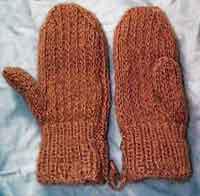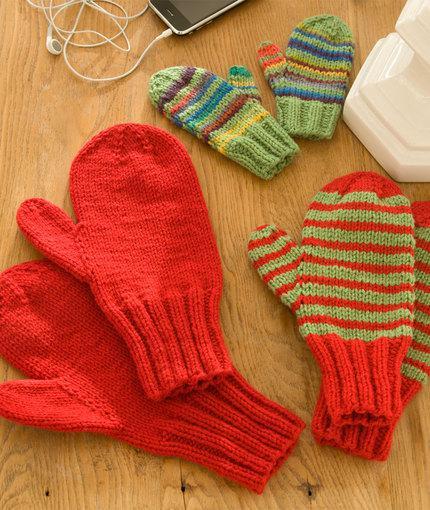The first image is the image on the left, the second image is the image on the right. For the images displayed, is the sentence "And at least one image there is somebody wearing mittens where the Fingers are not visible" factually correct? Answer yes or no. No. The first image is the image on the left, the second image is the image on the right. Considering the images on both sides, is "At least one mitten is being worn and at least one mitten is not." valid? Answer yes or no. No. 